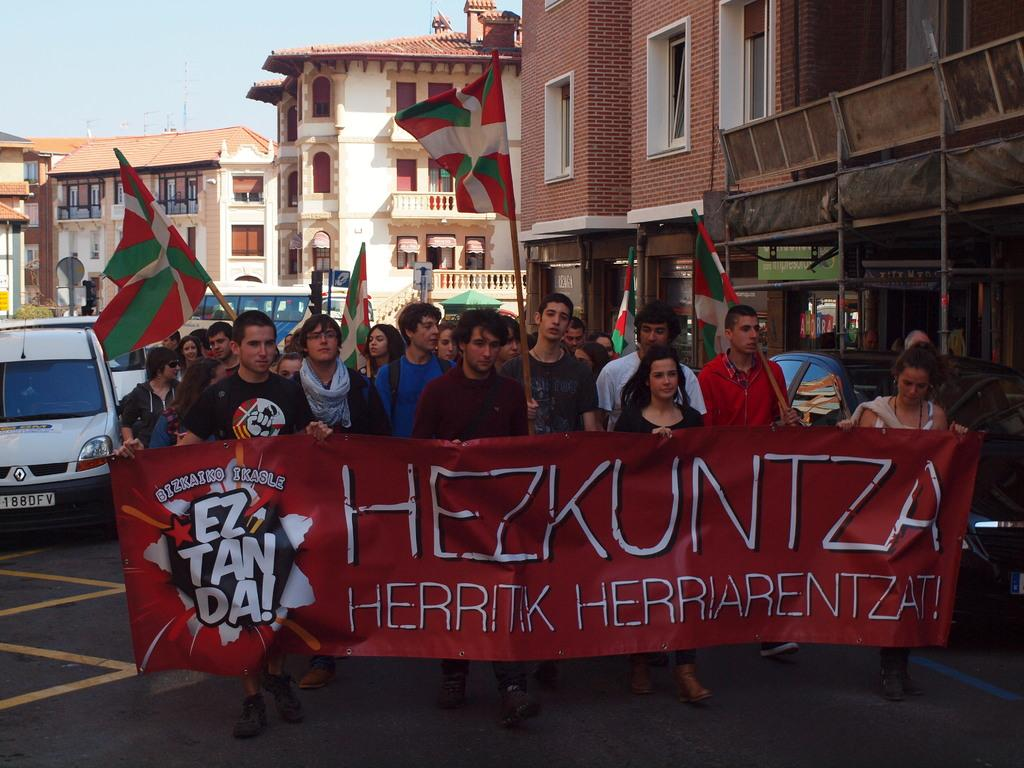What are the people in the image doing? The persons in the image are standing on the road. What else can be seen on the road? There is a vehicle on the road. What can be seen in the background of the image? There are buildings in the background of the image. What is visible in the sky in the image? The sky is visible in the image. What additional objects are present in the image? There are flags in the image. Can you tell me how many snails are crawling on the vehicle in the image? There are no snails present in the image; it only shows persons standing on the road, a vehicle, buildings in the background, the sky, and flags. What type of tooth is visible on the person standing on the road? There is no tooth visible on any person in the image. 